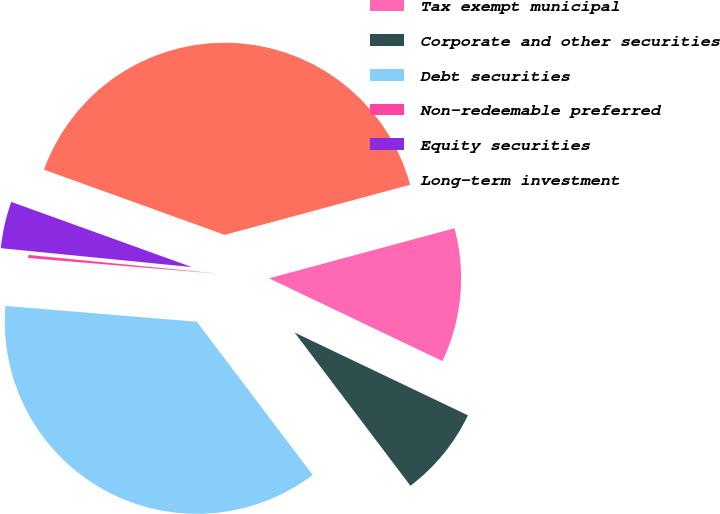Convert chart. <chart><loc_0><loc_0><loc_500><loc_500><pie_chart><fcel>Tax exempt municipal<fcel>Corporate and other securities<fcel>Debt securities<fcel>Non-redeemable preferred<fcel>Equity securities<fcel>Long-term investment<nl><fcel>11.29%<fcel>7.61%<fcel>36.61%<fcel>0.26%<fcel>3.94%<fcel>40.29%<nl></chart> 